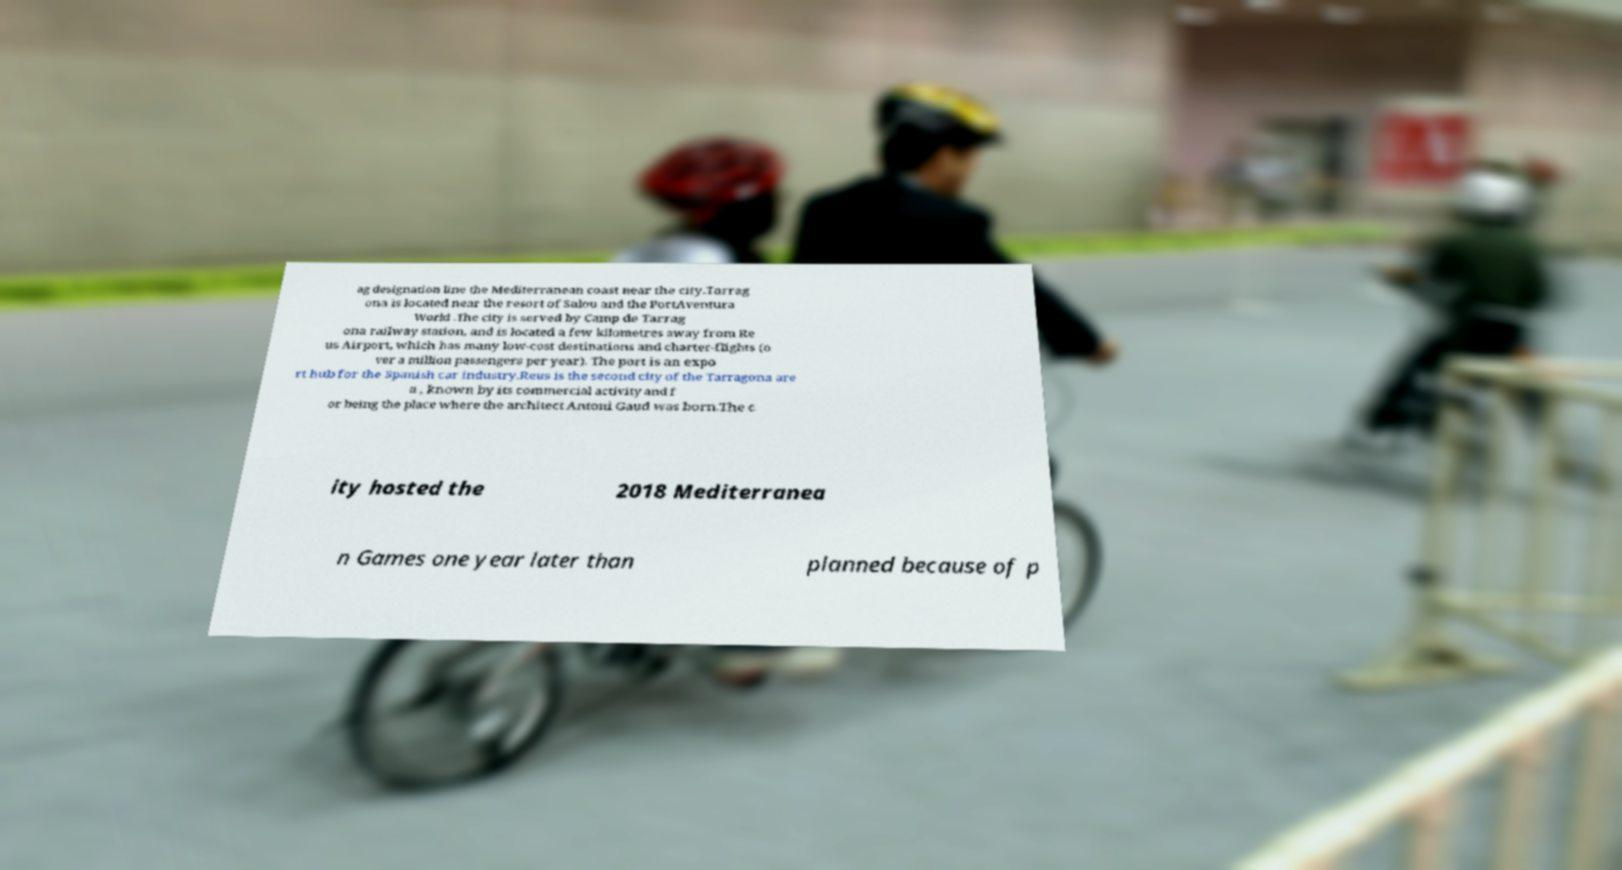Please read and relay the text visible in this image. What does it say? ag designation line the Mediterranean coast near the city.Tarrag ona is located near the resort of Salou and the PortAventura World .The city is served by Camp de Tarrag ona railway station, and is located a few kilometres away from Re us Airport, which has many low-cost destinations and charter-flights (o ver a million passengers per year). The port is an expo rt hub for the Spanish car industry.Reus is the second city of the Tarragona are a , known by its commercial activity and f or being the place where the architect Antoni Gaud was born.The c ity hosted the 2018 Mediterranea n Games one year later than planned because of p 